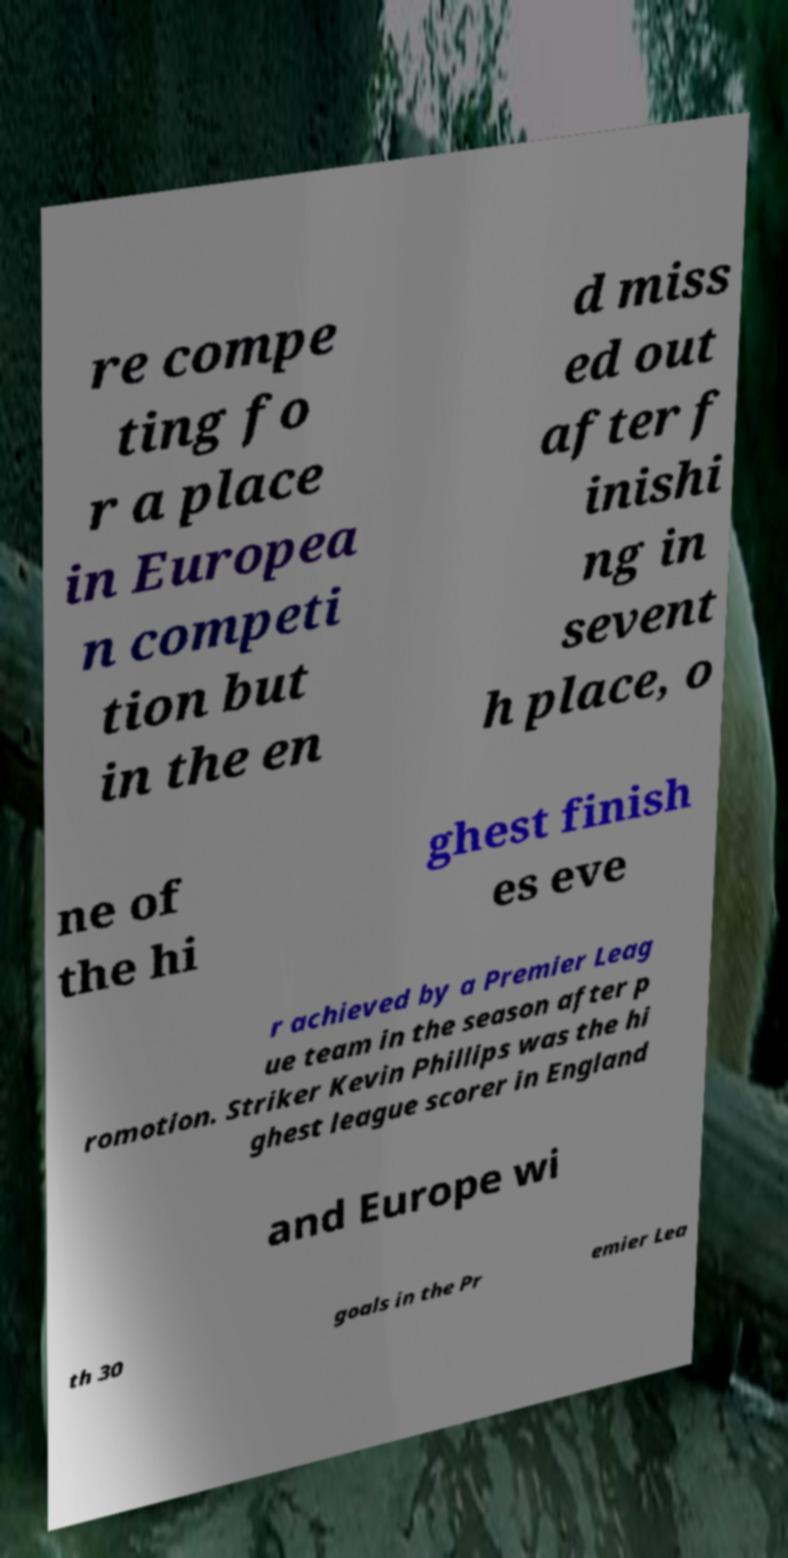For documentation purposes, I need the text within this image transcribed. Could you provide that? re compe ting fo r a place in Europea n competi tion but in the en d miss ed out after f inishi ng in sevent h place, o ne of the hi ghest finish es eve r achieved by a Premier Leag ue team in the season after p romotion. Striker Kevin Phillips was the hi ghest league scorer in England and Europe wi th 30 goals in the Pr emier Lea 